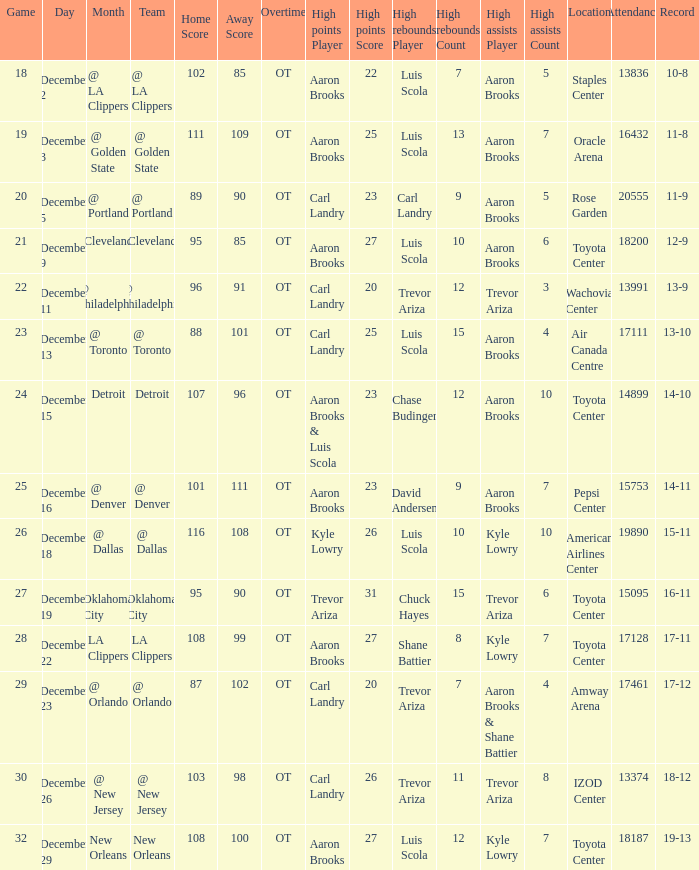In which location was the game where carl landry (25) achieved the most points played? Air Canada Centre 17111. 